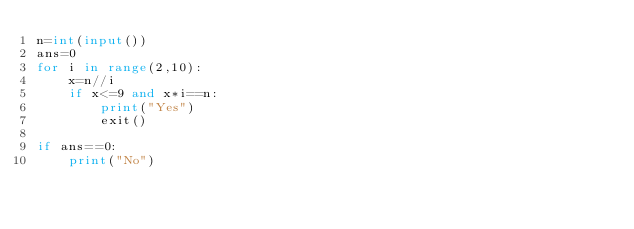<code> <loc_0><loc_0><loc_500><loc_500><_Python_>n=int(input())
ans=0
for i in range(2,10):
    x=n//i
    if x<=9 and x*i==n:
        print("Yes")
        exit()

if ans==0:
    print("No")</code> 